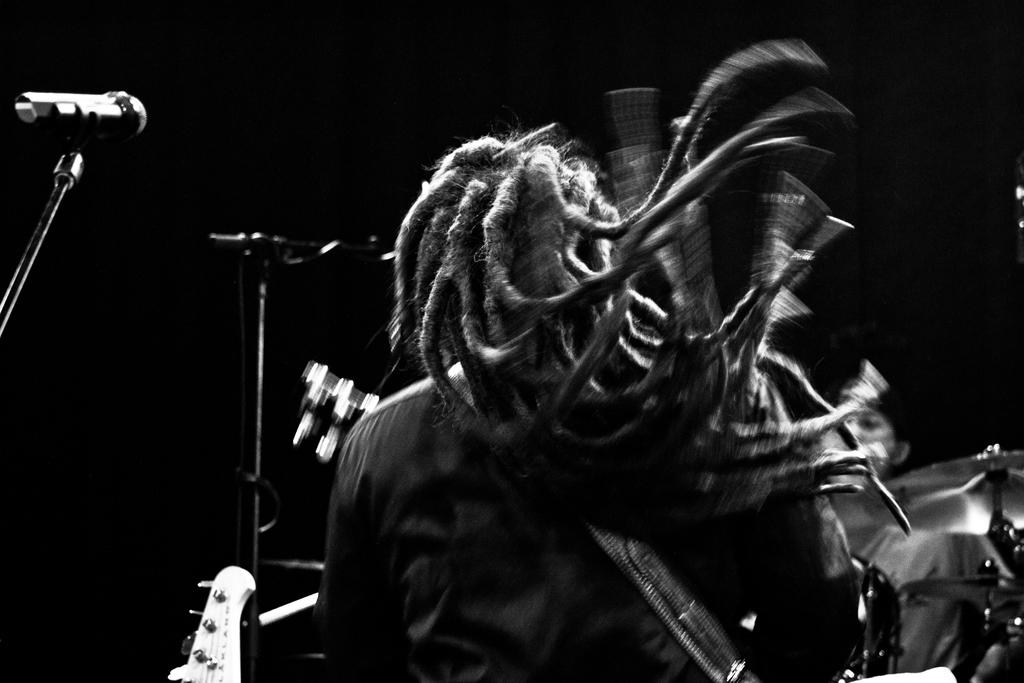Who is the main subject in the image? There is a person in the center of the image. What is the person wearing? The person is wearing a guitar. What other objects can be seen in the image? There are mic stands in the image. What is the color of the background in the image? The background of the image is black in color. What type of line is being drawn by the person in the image? There is no line being drawn by the person in the image; they are wearing a guitar and standing near mic stands. 